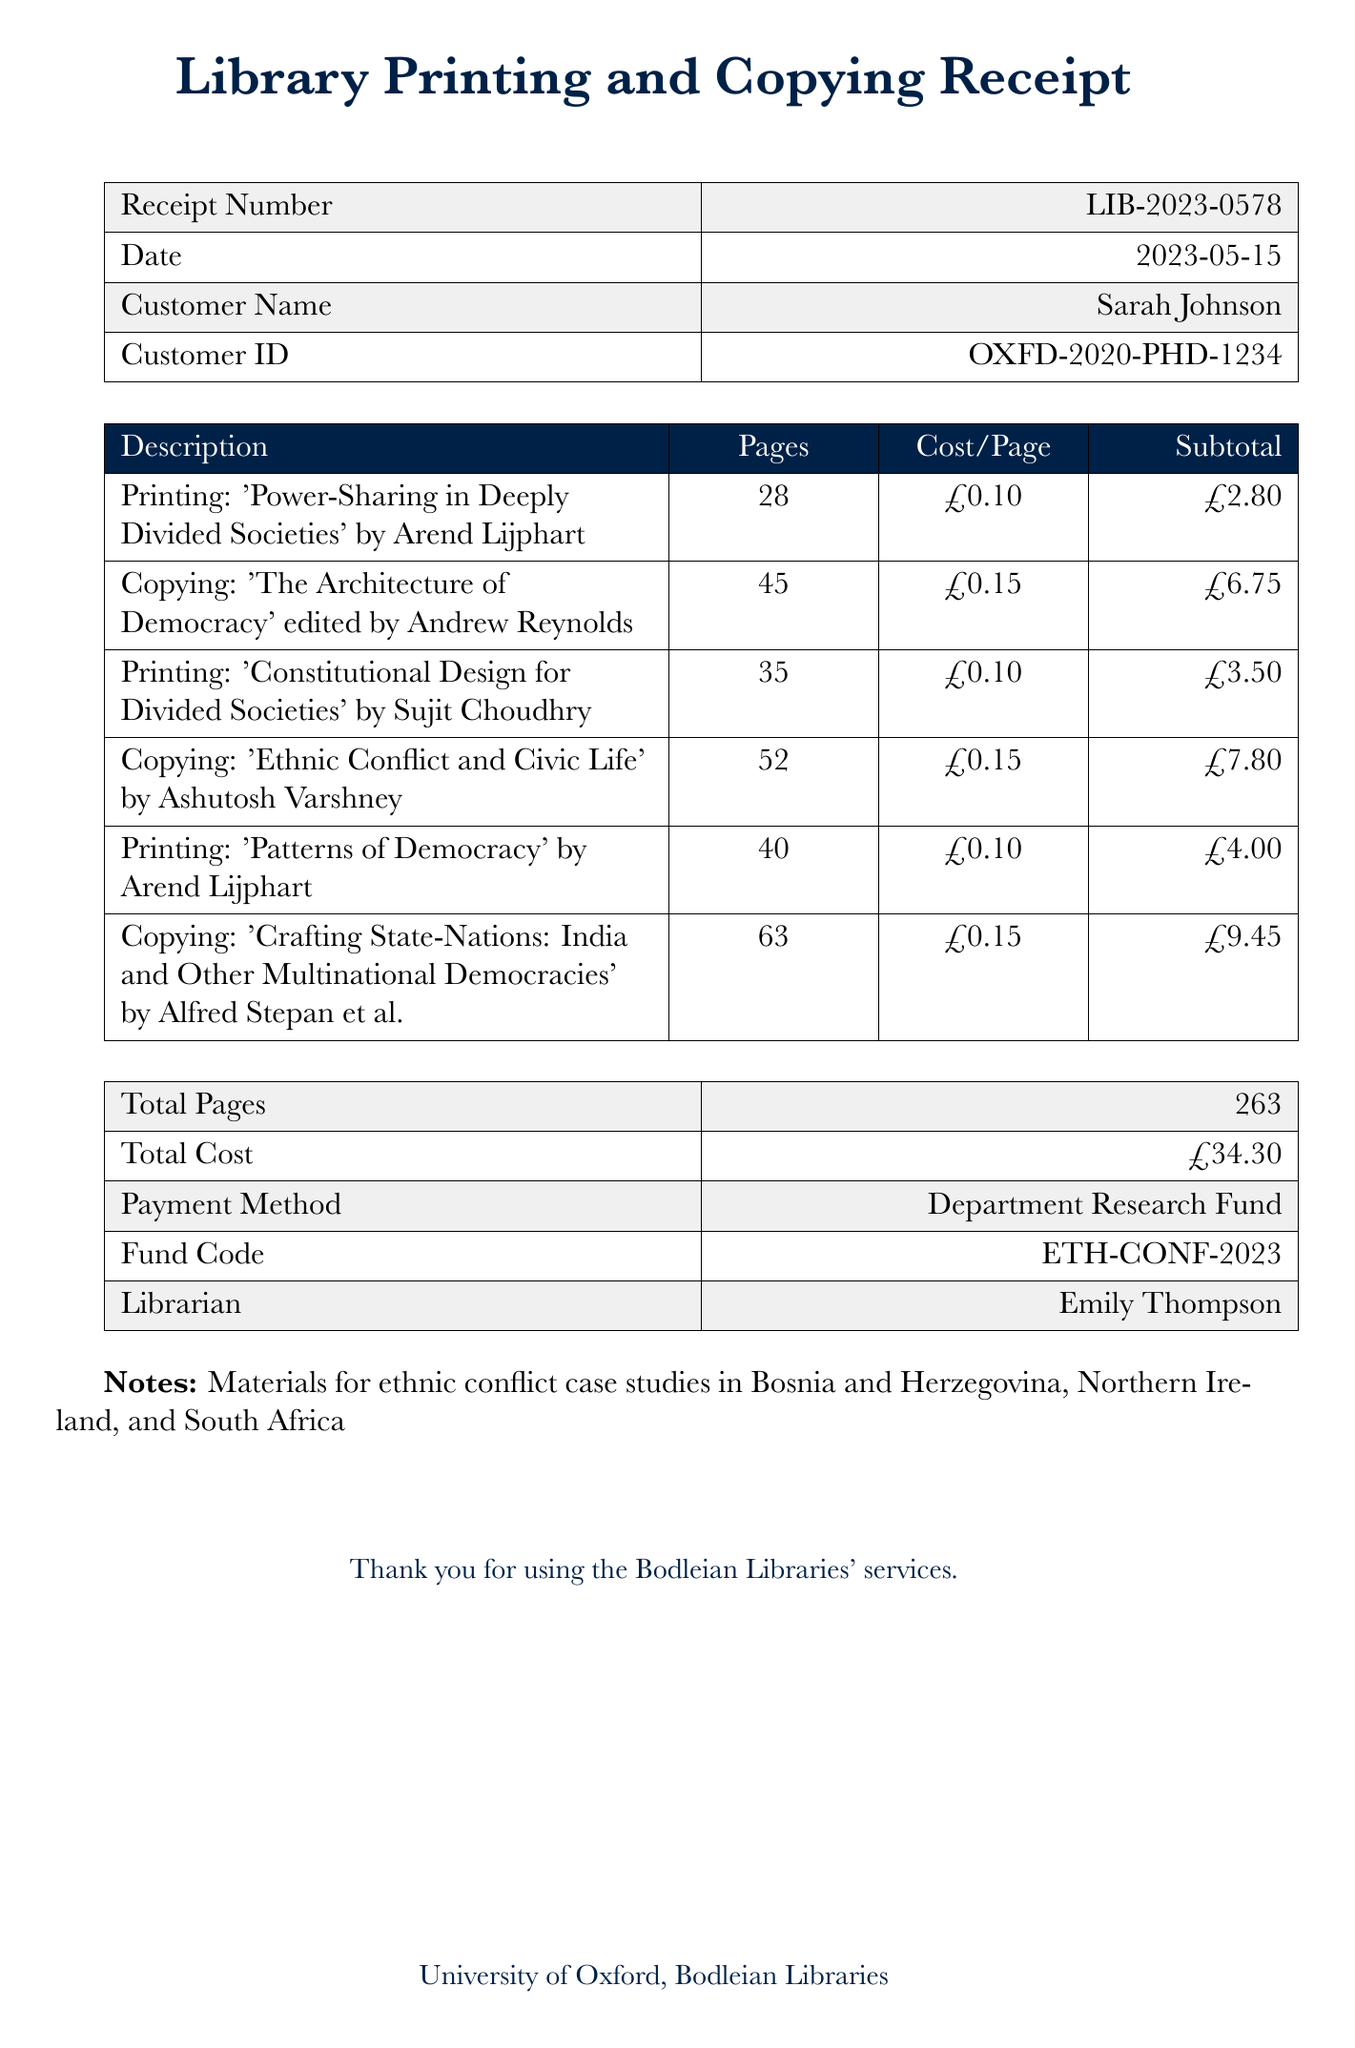What is the receipt number? The receipt number is listed at the top of the document as LIB-2023-0578.
Answer: LIB-2023-0578 Who is the customer? The customer name appears in the document under "Customer Name" as Sarah Johnson.
Answer: Sarah Johnson What is the total cost? The total cost is indicated in the summary section of the receipt as £34.30.
Answer: £34.30 How many pages were printed in total? The total number of pages is provided in the document as 263.
Answer: 263 What is the cost per page for printing? The document lists the cost per page for printing as £0.10.
Answer: £0.10 What payments method was used? The payment method is specified as "Department Research Fund" in the receipt.
Answer: Department Research Fund Which librarian processed the receipt? The librarian's name is mentioned in the document as Emily Thompson.
Answer: Emily Thompson How many copies were made of 'Ethnic Conflict and Civic Life'? The document shows that 52 pages were copied from 'Ethnic Conflict and Civic Life'.
Answer: 52 pages What is the title of the first printed material? The title of the first printed material is provided as 'Power-Sharing in Deeply Divided Societies'.
Answer: Power-Sharing in Deeply Divided Societies 